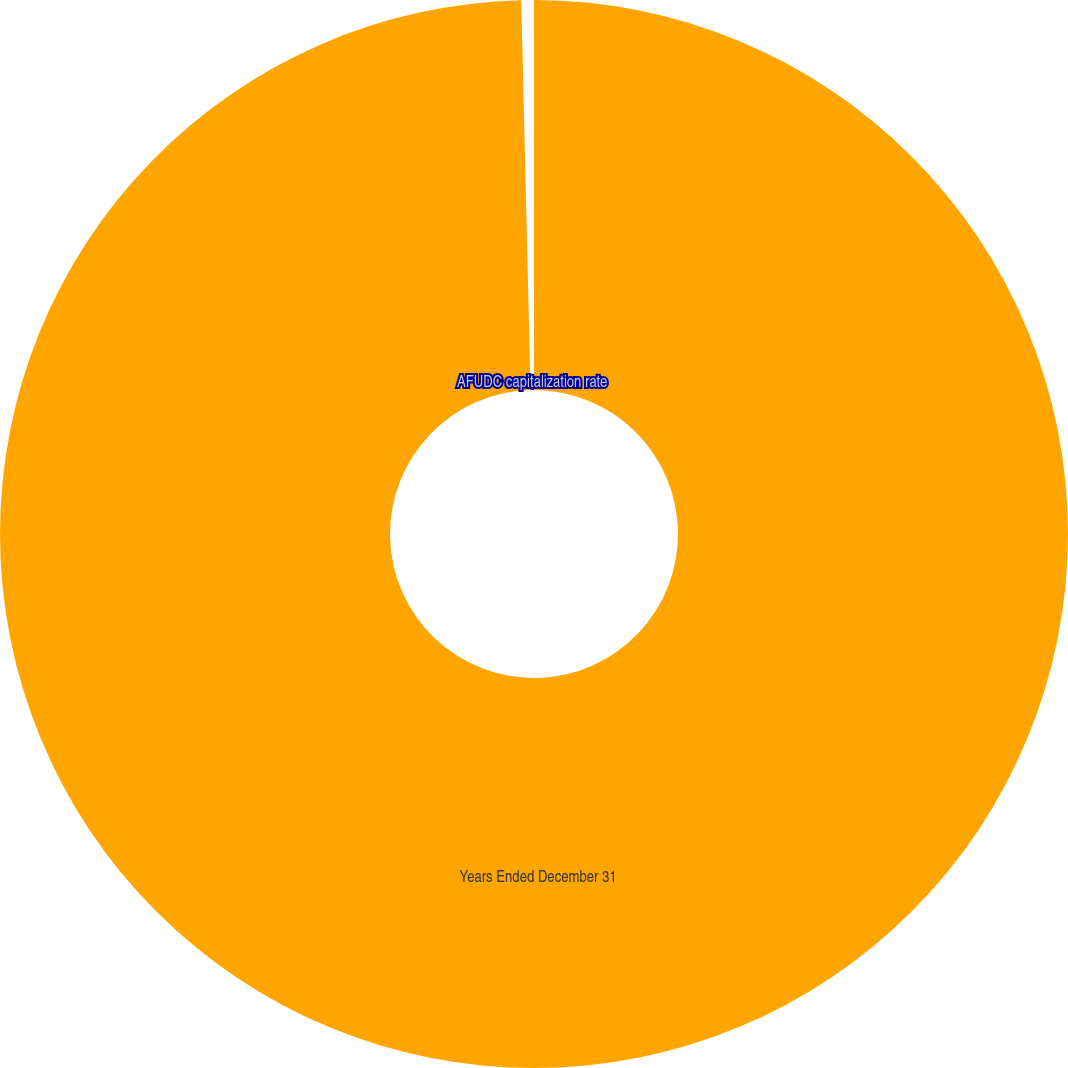<chart> <loc_0><loc_0><loc_500><loc_500><pie_chart><fcel>Years Ended December 31<fcel>AFUDC capitalization rate<nl><fcel>99.62%<fcel>0.38%<nl></chart> 